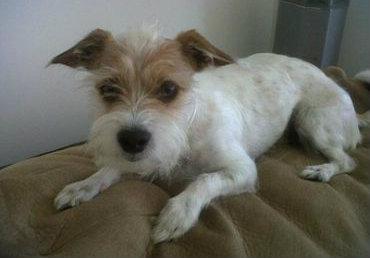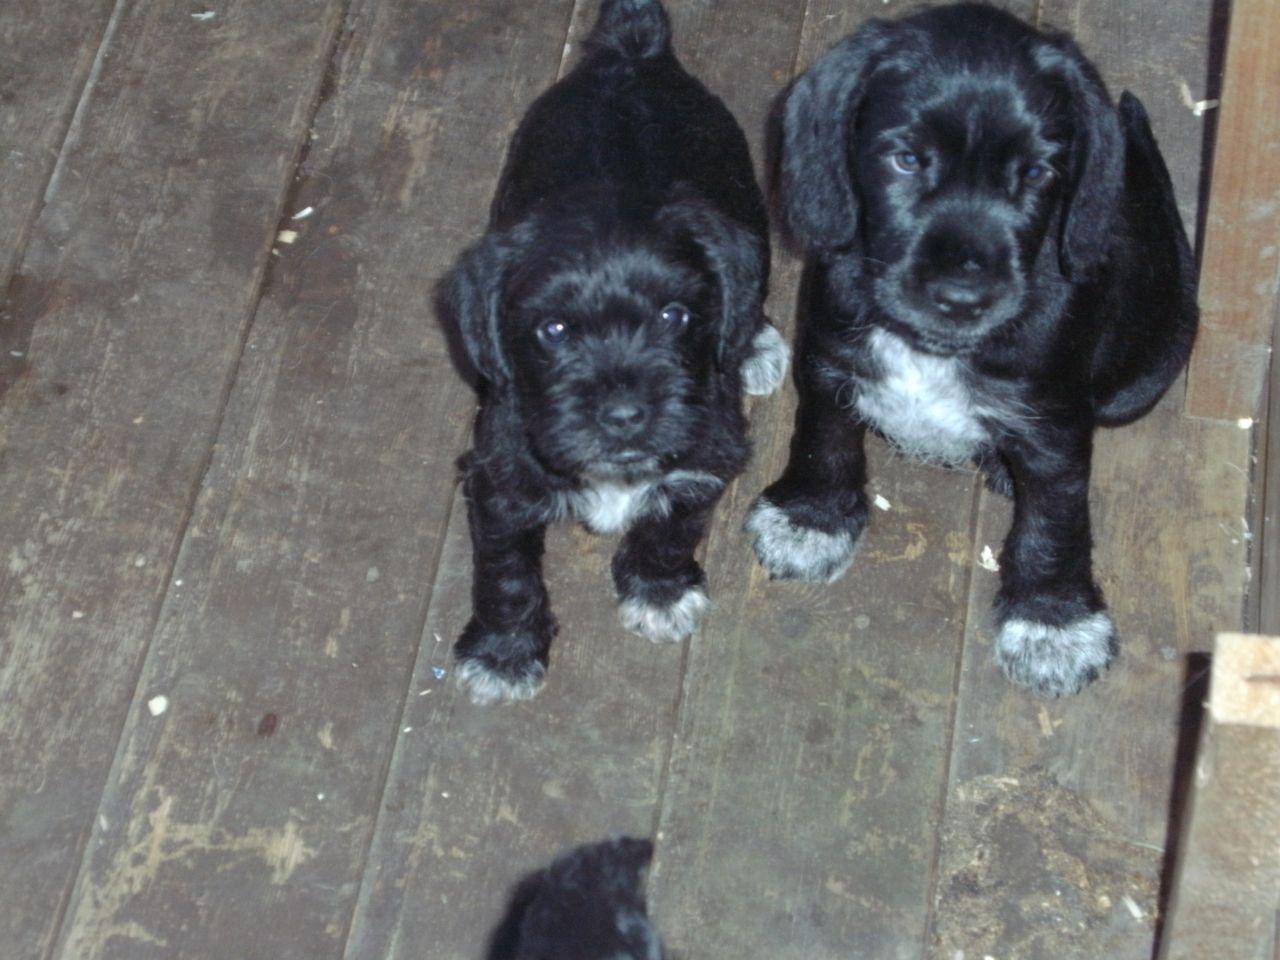The first image is the image on the left, the second image is the image on the right. Examine the images to the left and right. Is the description "Two black puppies are side-by-side and turned forward in the right image." accurate? Answer yes or no. Yes. The first image is the image on the left, the second image is the image on the right. Analyze the images presented: Is the assertion "There are three dogs waiting at attention." valid? Answer yes or no. Yes. 